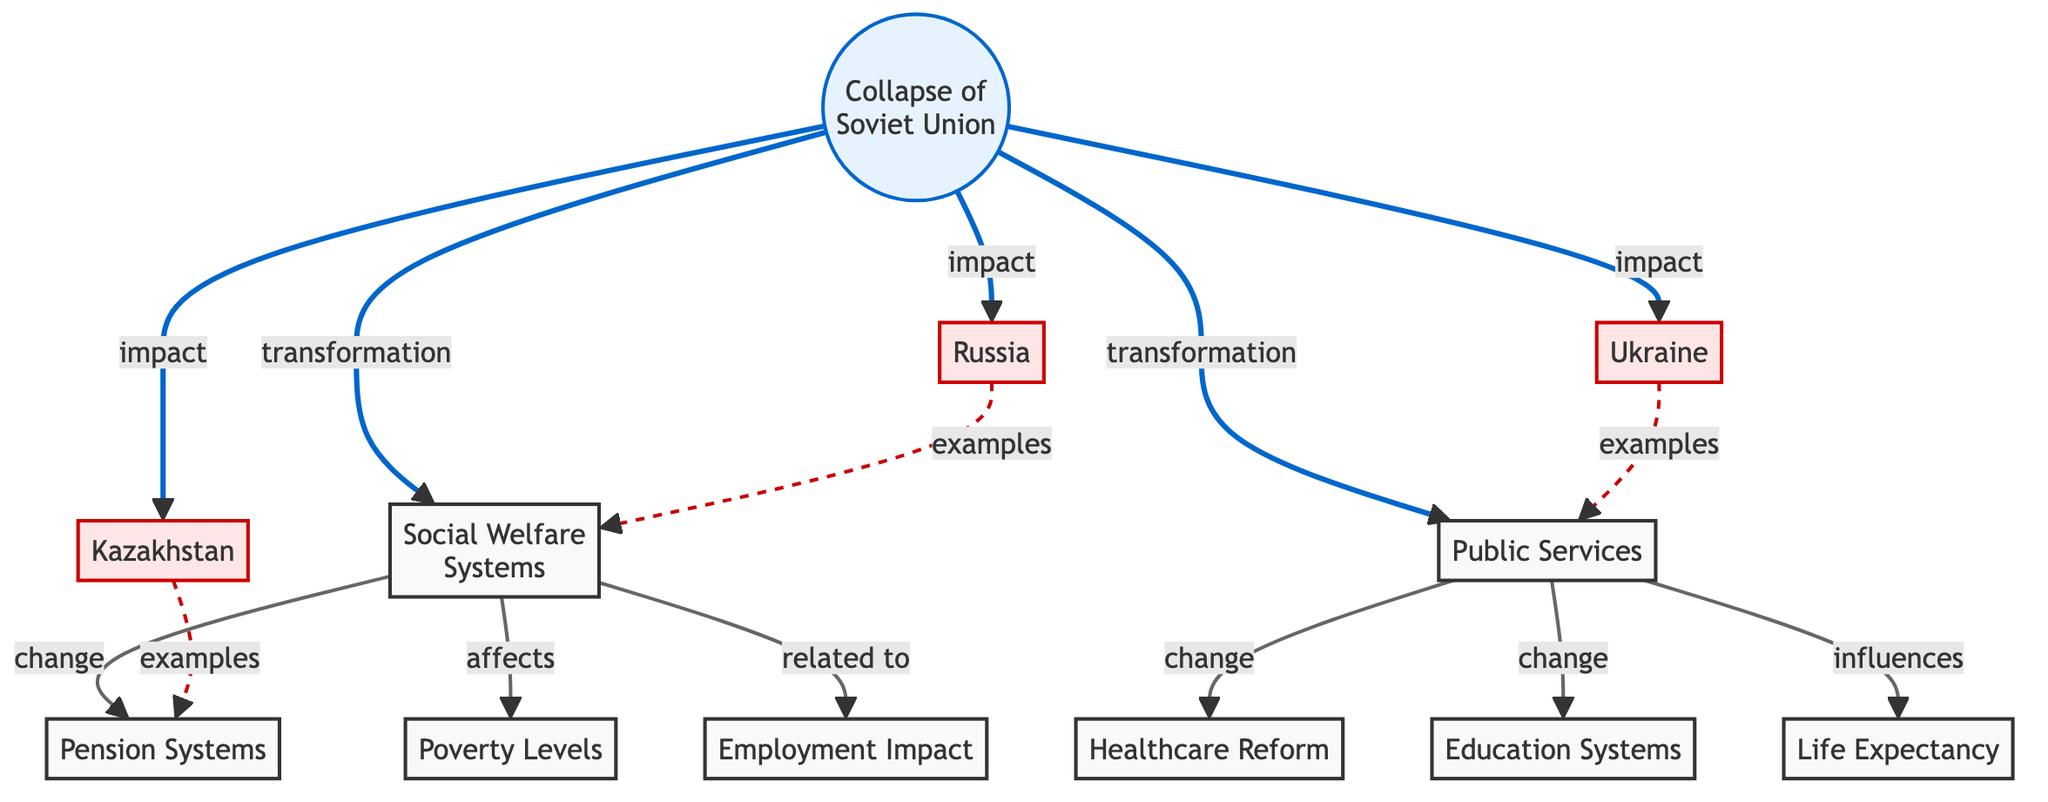What is the main event that initiated the transformation in social welfare systems? The diagram indicates that the "Collapse of Soviet Union" is the main event from which the transformation of social welfare systems begins. This can be observed by following the arrow directly leading from the "Collapse of Soviet Union" to "Social Welfare Systems" in the flowchart.
Answer: Collapse of Soviet Union How many countries are impacted by the collapse according to the diagram? The diagram shows three specific countries connected by arrows indicating the "impact" from the "Collapse of Soviet Union." Counting the arrows leads to the conclusion that Russia, Ukraine, and Kazakhstan are included.
Answer: Three Which public service is explicitly connected to healthcare reform? By following the arrow labeled "change" from "Public Services" to "Healthcare Reform," it is clear that healthcare reform directly relates to public services. This connection is demonstrated in the diagram's design.
Answer: Healthcare Reform What two aspects are influenced by public services? The diagram outlines that public services influence both "Life Expectancy" and "Employment Impact" through separate arrows pointing from "Public Services" to each of these nodes, indicating their relationship.
Answer: Life Expectancy, Employment Impact Which country is an example relating specifically to pension systems? The diagram uses a dashed arrow to connect "Kazakhstan" with "Pension Systems," indicating that Kazakhstan serves as an example in this area. The style of the arrow further emphasizes the nature of this relationship.
Answer: Kazakhstan What type of impact is indicated for Ukraine in the diagram? The flowchart shows a direct "impact" from "Collapse of Soviet Union" to "Public Services," with a line leading specifically to Ukraine, demonstrating that Ukraine's situation regarding public services is a significant consequence.
Answer: Impact How are poverty levels related to social welfare systems? The diagram indicates a relationship where "Social Welfare Systems" affects "Poverty Levels." This connection is displayed by following the arrow labeled "affects" from the social welfare nodes to poverty levels, illustrating the influence.
Answer: Affects What aspect of public services has a direct change related to education systems? The diagram highlights a direct connection labeled "change" from "Public Services" to "Education Systems," indicating that this is an essential area undergoing transformation in response to changes in public services.
Answer: Education Systems How does the collapse of the Soviet Union influence employment impact? The diagram shows a relationship where the "Collapse of Soviet Union" is related to "Employment Impact" through the "Social Welfare Systems," indicating the influence of the initial event on employment contexts in the successor states.
Answer: Related to 